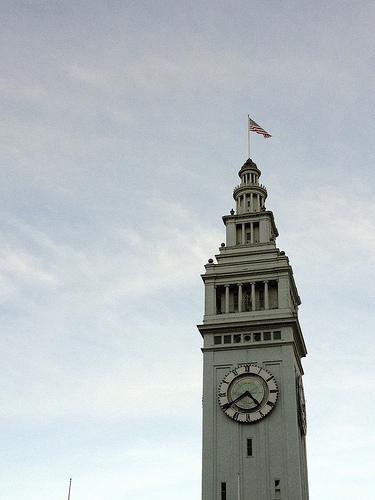Analyze the visual sentiment of the image based on its content. The visual sentiment of the image is peaceful, with a soft and calm atmosphere created by the white clouds in the blue sky. Mention any architectural components present in the image, other than the tower. Windows, a column, and a flag on top of a structure are other architectural components in the image. What type of numerals are present on the clock, and provide an example? Roman numerals are present on the clock, such as "X" for 10 or "IX" for 9. List the weather and sky-related elements in the image. White clouds in the blue sky, forming part of the cloudy atmosphere. Identify the object positioned atop the tall stone building. An American flag is positioned atop the tall stone building. What is the primary tall structure in the image, and what color is it? The primary tall structure in the image is a white clock tower. How many windows are there under the clock, and what do they resemble? There are three windows under the clock. What is the color of the clock's hands and what are they made of? The clock's hands are black in color. Examine the clock's features and provide a description of its appearance. The clock is round with black hands, roman numerals, and is located on a tower. Express the meaning demonstrated in the image. A tall stone structure with a clock and an American flag on top, surrounded by white clouds in a blue sky Is there a green column at X:243 Y:291, Width:15, and Height:15? The given coordinates and size match a column, but its color is not mentioned in the image details. Is the clock square with X:167 Y:370, Width:156, and Height:156? The given coordinates and size are accurate, but the clock is round instead of square. Is the hand on the clock white with X:214 Y:393, Width:38, and Height:38? The given coordinates and size match a hand, but the hand is black, not white. Examine the image and describe the primary time indicators on the clock. Black clock hands Identify the writing system used on the clock. Roman numerals What is the main object located in the center of the image? A clock tower Describe the object located on the top of the tower. An American flag List the fundamental elements of the scene. Tower, clock, American flag, white clouds, blue sky, and Roman numerals What do the hands of the clock indicate? Time Identify the round object in the image. A clock Is the tower located at X:195 Y:304 with Width:75 and Height:75? The given coordinates and size are actually for a window, not the tower. What is the predominant emotion portrayed in this image? No emotions What type of numerical system is used on the clock? Roman numeral system What numbers can you identify on the clock in the image? Roman numerals IX, X, XII Describe the object that indicates the time on the clock. Black hands Mention some of the objects that can be found in the sky in the image. White clouds What are the colors of the scene in the image? White tower, white clouds, blue sky, black clock hands, and American flag Choose the right caption for the picture: (A) A modern building with no clock (B) A tall stone building with a clock and flag (C) A low building with no flag B Explain the image's scenario in a simple and straightforward way. A tower with a clock and an American flag, surrounded by white clouds in the sky. Is the flag a British flag located at X:238 Y:107, Width:47, and Height:47? The given coordinates and size match a flag, but it is an American flag, not a British one. What is the primary color of the tower? White Are the clouds gray and located at X:101 Y:385 with Width:23 and Height:23? The given coordinates and size match existing clouds, but they are white rather than gray. Count the number of windows under the clock. Three windows 